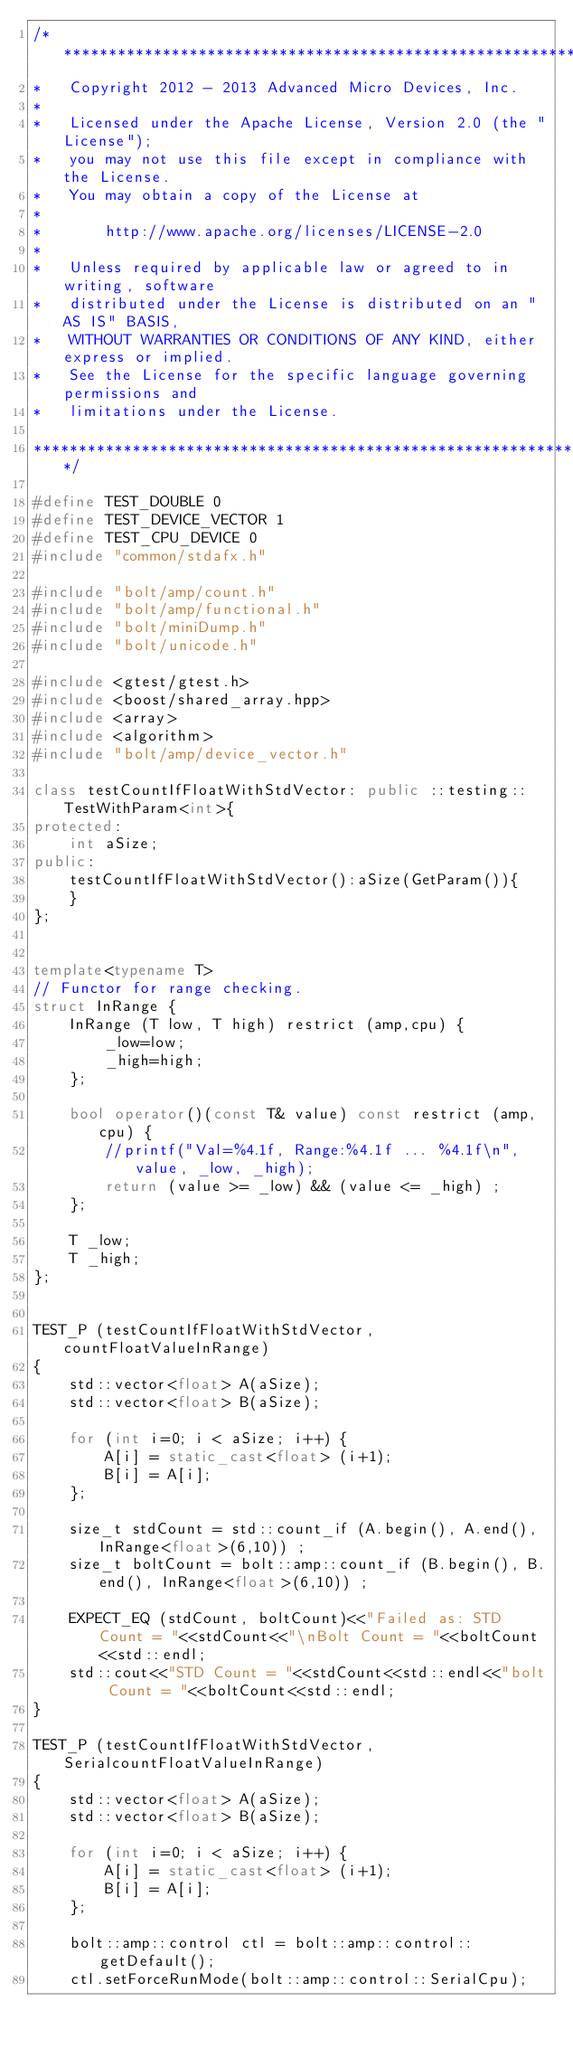Convert code to text. <code><loc_0><loc_0><loc_500><loc_500><_C++_>/***************************************************************************
*   Copyright 2012 - 2013 Advanced Micro Devices, Inc.
*
*   Licensed under the Apache License, Version 2.0 (the "License");
*   you may not use this file except in compliance with the License.
*   You may obtain a copy of the License at
*
*       http://www.apache.org/licenses/LICENSE-2.0
*
*   Unless required by applicable law or agreed to in writing, software
*   distributed under the License is distributed on an "AS IS" BASIS,
*   WITHOUT WARRANTIES OR CONDITIONS OF ANY KIND, either express or implied.
*   See the License for the specific language governing permissions and
*   limitations under the License.

***************************************************************************/

#define TEST_DOUBLE 0
#define TEST_DEVICE_VECTOR 1
#define TEST_CPU_DEVICE 0
#include "common/stdafx.h"

#include "bolt/amp/count.h"
#include "bolt/amp/functional.h"
#include "bolt/miniDump.h"
#include "bolt/unicode.h"

#include <gtest/gtest.h>
#include <boost/shared_array.hpp>
#include <array>
#include <algorithm>
#include "bolt/amp/device_vector.h"

class testCountIfFloatWithStdVector: public ::testing::TestWithParam<int>{
protected:
    int aSize;
public:
    testCountIfFloatWithStdVector():aSize(GetParam()){
    }
};


template<typename T>
// Functor for range checking.
struct InRange {
    InRange (T low, T high) restrict (amp,cpu) {
        _low=low;
        _high=high;
    };

    bool operator()(const T& value) const restrict (amp,cpu) {
        //printf("Val=%4.1f, Range:%4.1f ... %4.1f\n", value, _low, _high);
        return (value >= _low) && (value <= _high) ;
    };

    T _low;
    T _high;
};


TEST_P (testCountIfFloatWithStdVector, countFloatValueInRange)
{
    std::vector<float> A(aSize);
    std::vector<float> B(aSize);

    for (int i=0; i < aSize; i++) {
        A[i] = static_cast<float> (i+1);
        B[i] = A[i];
    };

    size_t stdCount = std::count_if (A.begin(), A.end(), InRange<float>(6,10)) ;
    size_t boltCount = bolt::amp::count_if (B.begin(), B.end(), InRange<float>(6,10)) ;

    EXPECT_EQ (stdCount, boltCount)<<"Failed as: STD Count = "<<stdCount<<"\nBolt Count = "<<boltCount<<std::endl;
    std::cout<<"STD Count = "<<stdCount<<std::endl<<"bolt Count = "<<boltCount<<std::endl;
}

TEST_P (testCountIfFloatWithStdVector, SerialcountFloatValueInRange)
{
    std::vector<float> A(aSize);
    std::vector<float> B(aSize);

    for (int i=0; i < aSize; i++) {
        A[i] = static_cast<float> (i+1);
        B[i] = A[i];
    };

    bolt::amp::control ctl = bolt::amp::control::getDefault();
    ctl.setForceRunMode(bolt::amp::control::SerialCpu);
</code> 